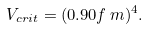Convert formula to latex. <formula><loc_0><loc_0><loc_500><loc_500>V _ { c r i t } = ( 0 . 9 0 f \, m ) ^ { 4 } .</formula> 